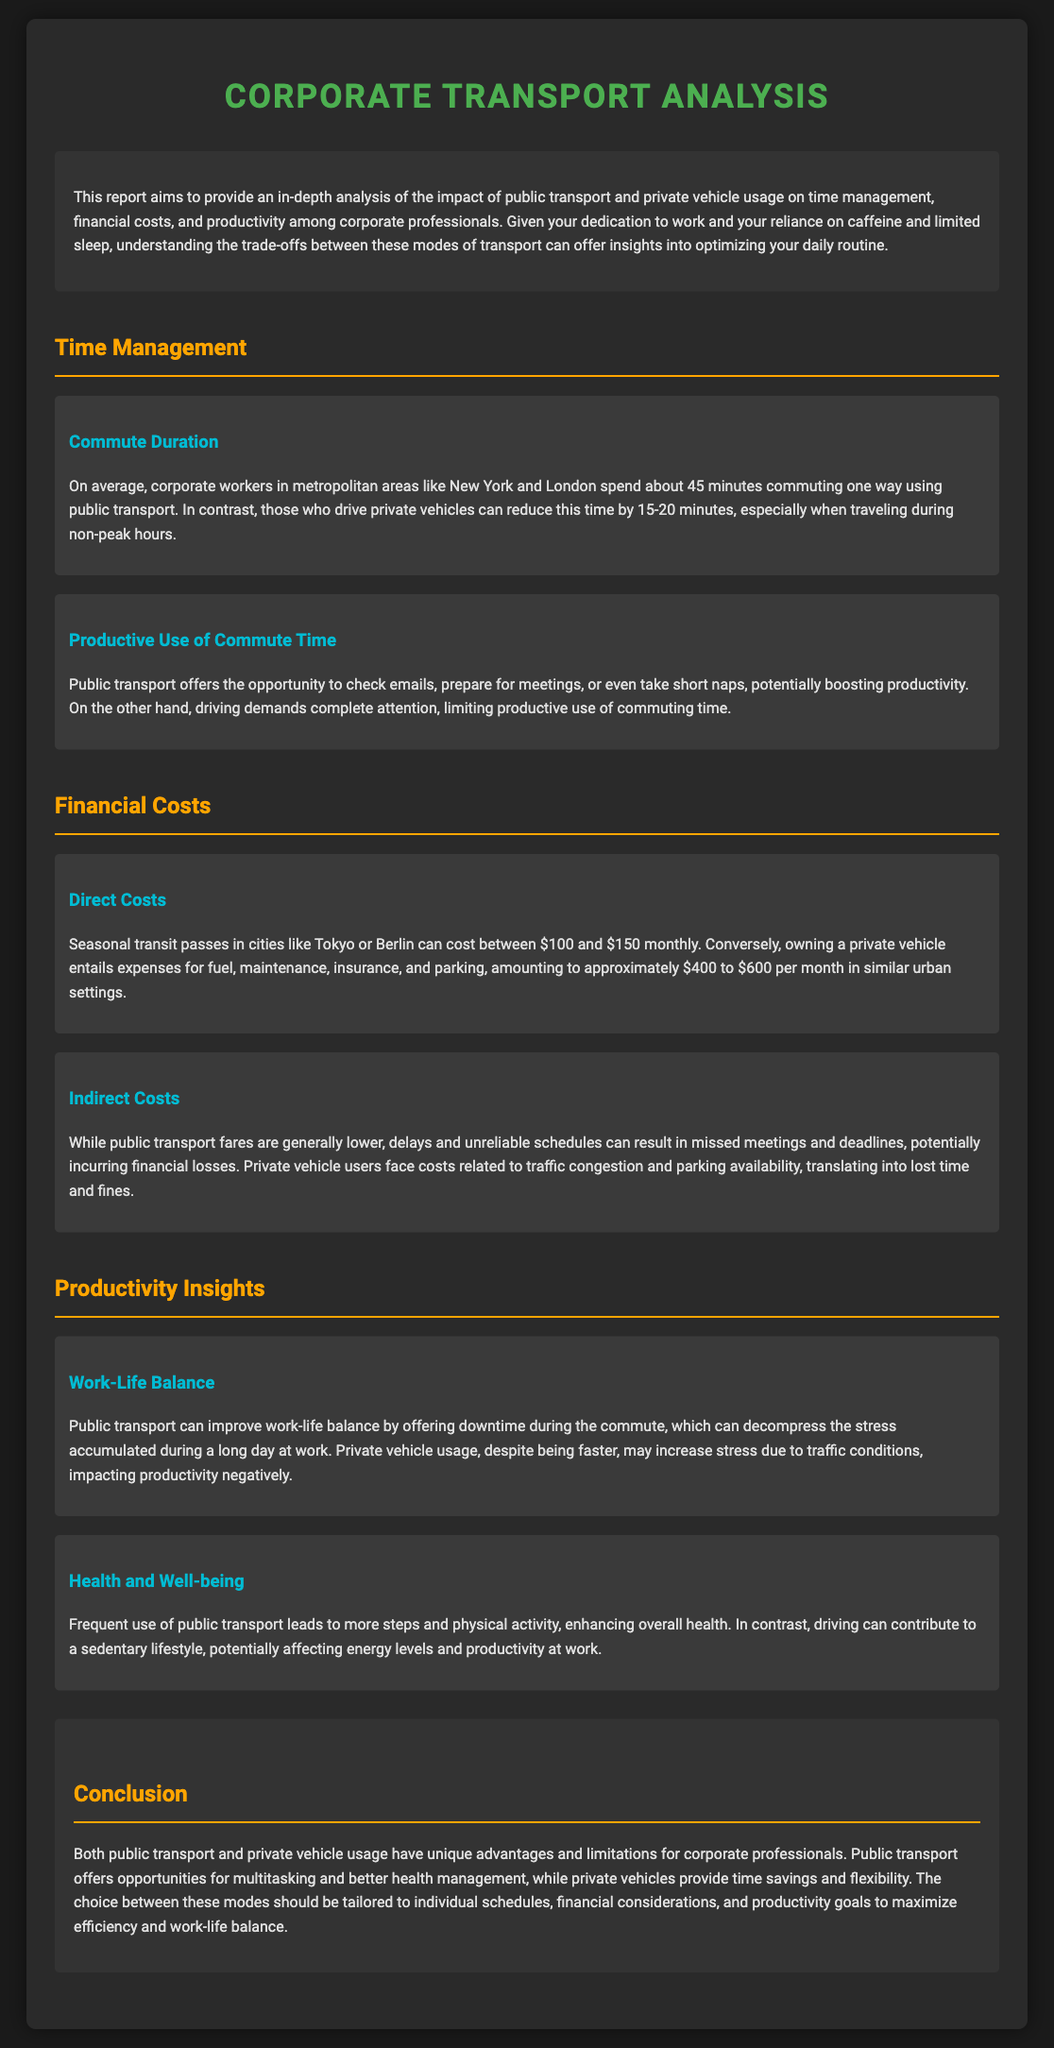What is the average commute duration for public transport users? The average commute duration for public transport users is stated as 45 minutes one way.
Answer: 45 minutes How much can private vehicle users reduce their commute time? The document mentions that private vehicle users can reduce their commute time by 15-20 minutes, especially during non-peak hours.
Answer: 15-20 minutes What is the monthly cost range for owning a private vehicle? The document outlines that owning a private vehicle entails expenses amounting to approximately $400 to $600 per month.
Answer: $400 to $600 What is one advantage of public transport regarding productivity? The report highlights that public transport offers the opportunity to check emails, prepare for meetings, or take short naps, potentially boosting productivity.
Answer: Boosting productivity What health benefit is associated with frequent use of public transport? The document states that frequent use of public transport leads to more steps and physical activity, enhancing overall health.
Answer: Enhancing overall health What is a negative impact of private vehicle usage mentioned in the report? The report notes that private vehicle usage may increase stress due to traffic conditions, which negatively impacts productivity.
Answer: Increased stress What is the primary focus of this traffic report? The main focus of the report is to provide an analysis of the impact of public transport and private vehicle usage on time management, financial costs, and productivity among corporate professionals.
Answer: Time management, financial costs, and productivity What role does work-life balance play in public transport usage according to the document? The report claims that public transport can improve work-life balance by offering downtime during the commute.
Answer: Improve work-life balance What are the indirect costs of public transport delays? The document states that delays and unreliable schedules can result in missed meetings and deadlines, potentially incurring financial losses.
Answer: Missed meetings and deadlines 